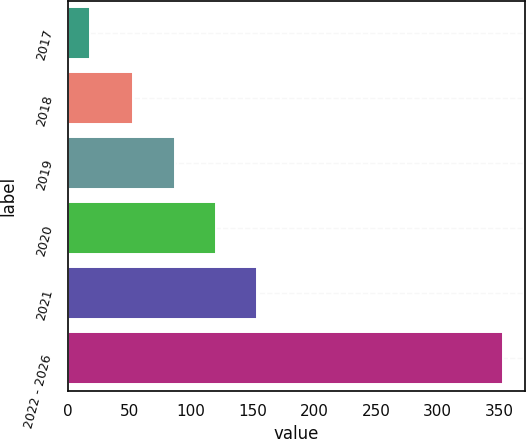Convert chart to OTSL. <chart><loc_0><loc_0><loc_500><loc_500><bar_chart><fcel>2017<fcel>2018<fcel>2019<fcel>2020<fcel>2021<fcel>2022 - 2026<nl><fcel>18<fcel>53<fcel>86.5<fcel>120<fcel>153.5<fcel>353<nl></chart> 